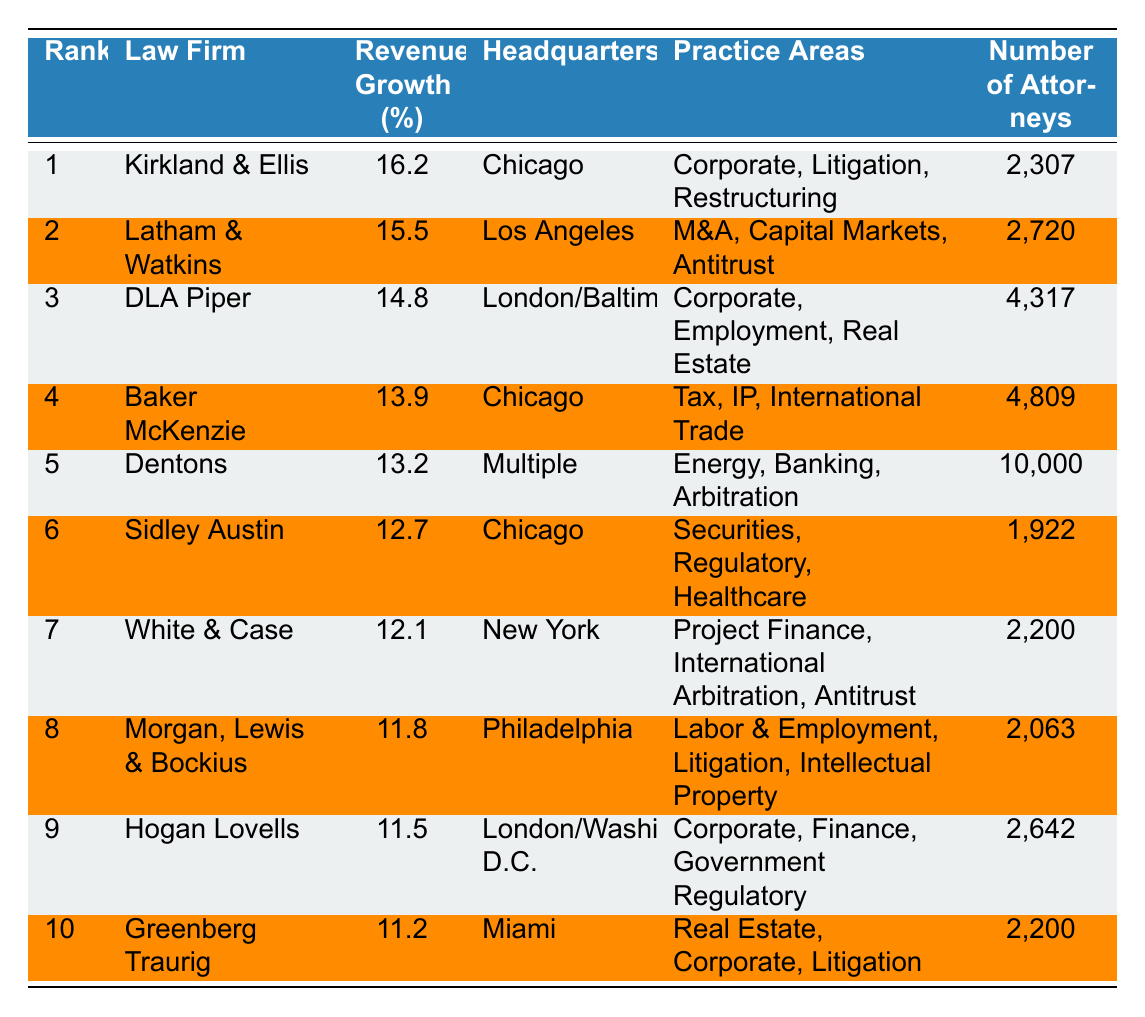What is the revenue growth percentage of Kirkland & Ellis? The table shows that Kirkland & Ellis has a revenue growth percentage of 16.2%.
Answer: 16.2% Which law firm has the highest revenue growth percentage? Looking at the "Revenue Growth (%)" column, Kirkland & Ellis has the highest value at 16.2%.
Answer: Kirkland & Ellis What is the headquarters location of Baker McKenzie? The table indicates that Baker McKenzie is headquartered in Chicago.
Answer: Chicago How many attorneys does Dentons have? According to the table, Dentons has 10,000 attorneys.
Answer: 10,000 What is the average revenue growth percentage of the top three law firms? The revenue growth percentages of the top three firms are 16.2%, 15.5%, and 14.8%. Summing these gives 46.5%, and dividing by 3 gives an average of 15.5%.
Answer: 15.5% Is it true that White & Case has more attorneys than Hogan Lovells? The table shows White & Case has 2,200 attorneys and Hogan Lovells has 2,642 attorneys. Since 2,200 is less than 2,642, the statement is false.
Answer: False Which law firm has the second-highest revenue growth and what is its growth percentage? The second-highest revenue growth percentage is 15.5% for Latham & Watkins as seen in the "Revenue Growth (%)" column.
Answer: Latham & Watkins, 15.5% What is the difference in revenue growth percentage between the top-ranking law firm and the law firm in fifth place? Kirkland & Ellis has 16.2% revenue growth and Dentons has 13.2%. The difference is calculated as 16.2% - 13.2% = 3%.
Answer: 3% Are there more total attorneys in Baker McKenzie than in DLA Piper? Baker McKenzie has 4,809 attorneys and DLA Piper has 4,317 attorneys. 4,809 is greater than 4,317, so the statement is true.
Answer: True What law firm has a revenue growth percentage closest to 12%? The firms with revenue growth percentages near 12% are Sidley Austin with 12.7% and White & Case with 12.1%. Comparing these, White & Case at 12.1% is closest but below 12%.
Answer: White & Case (12.1%) 